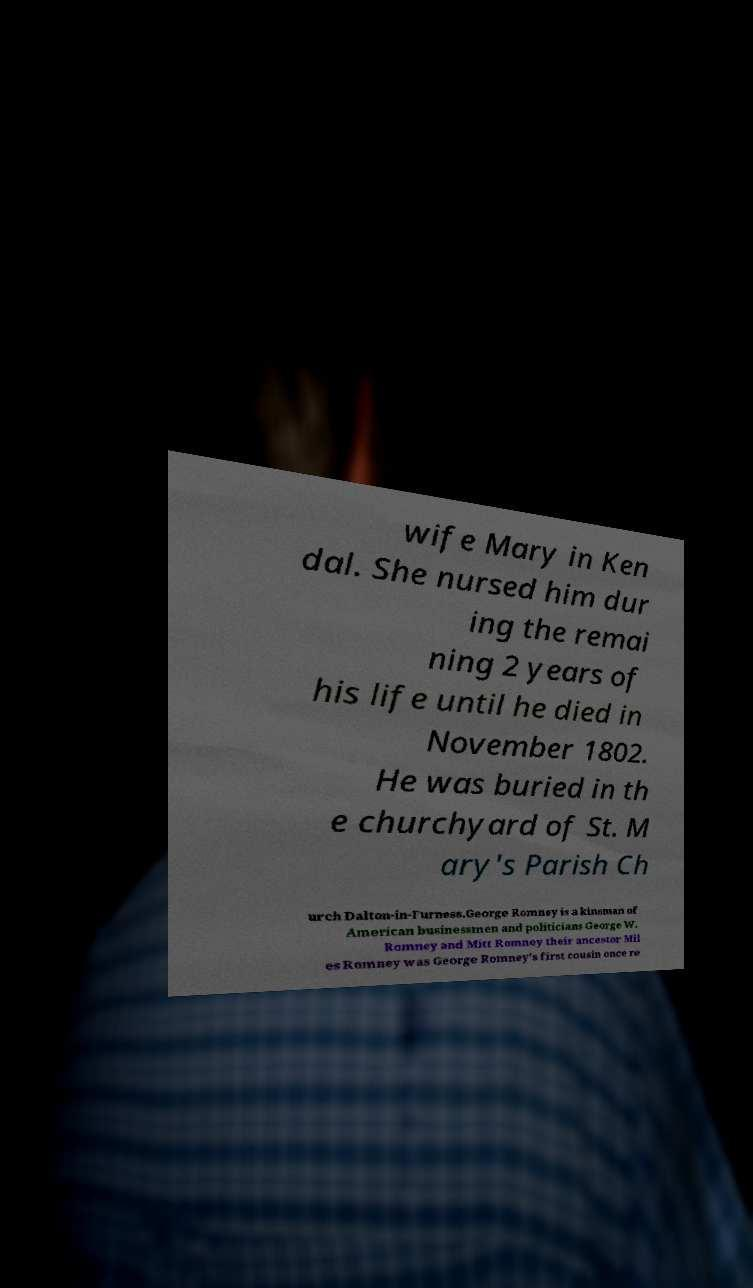For documentation purposes, I need the text within this image transcribed. Could you provide that? wife Mary in Ken dal. She nursed him dur ing the remai ning 2 years of his life until he died in November 1802. He was buried in th e churchyard of St. M ary's Parish Ch urch Dalton-in-Furness.George Romney is a kinsman of American businessmen and politicians George W. Romney and Mitt Romney their ancestor Mil es Romney was George Romney's first cousin once re 